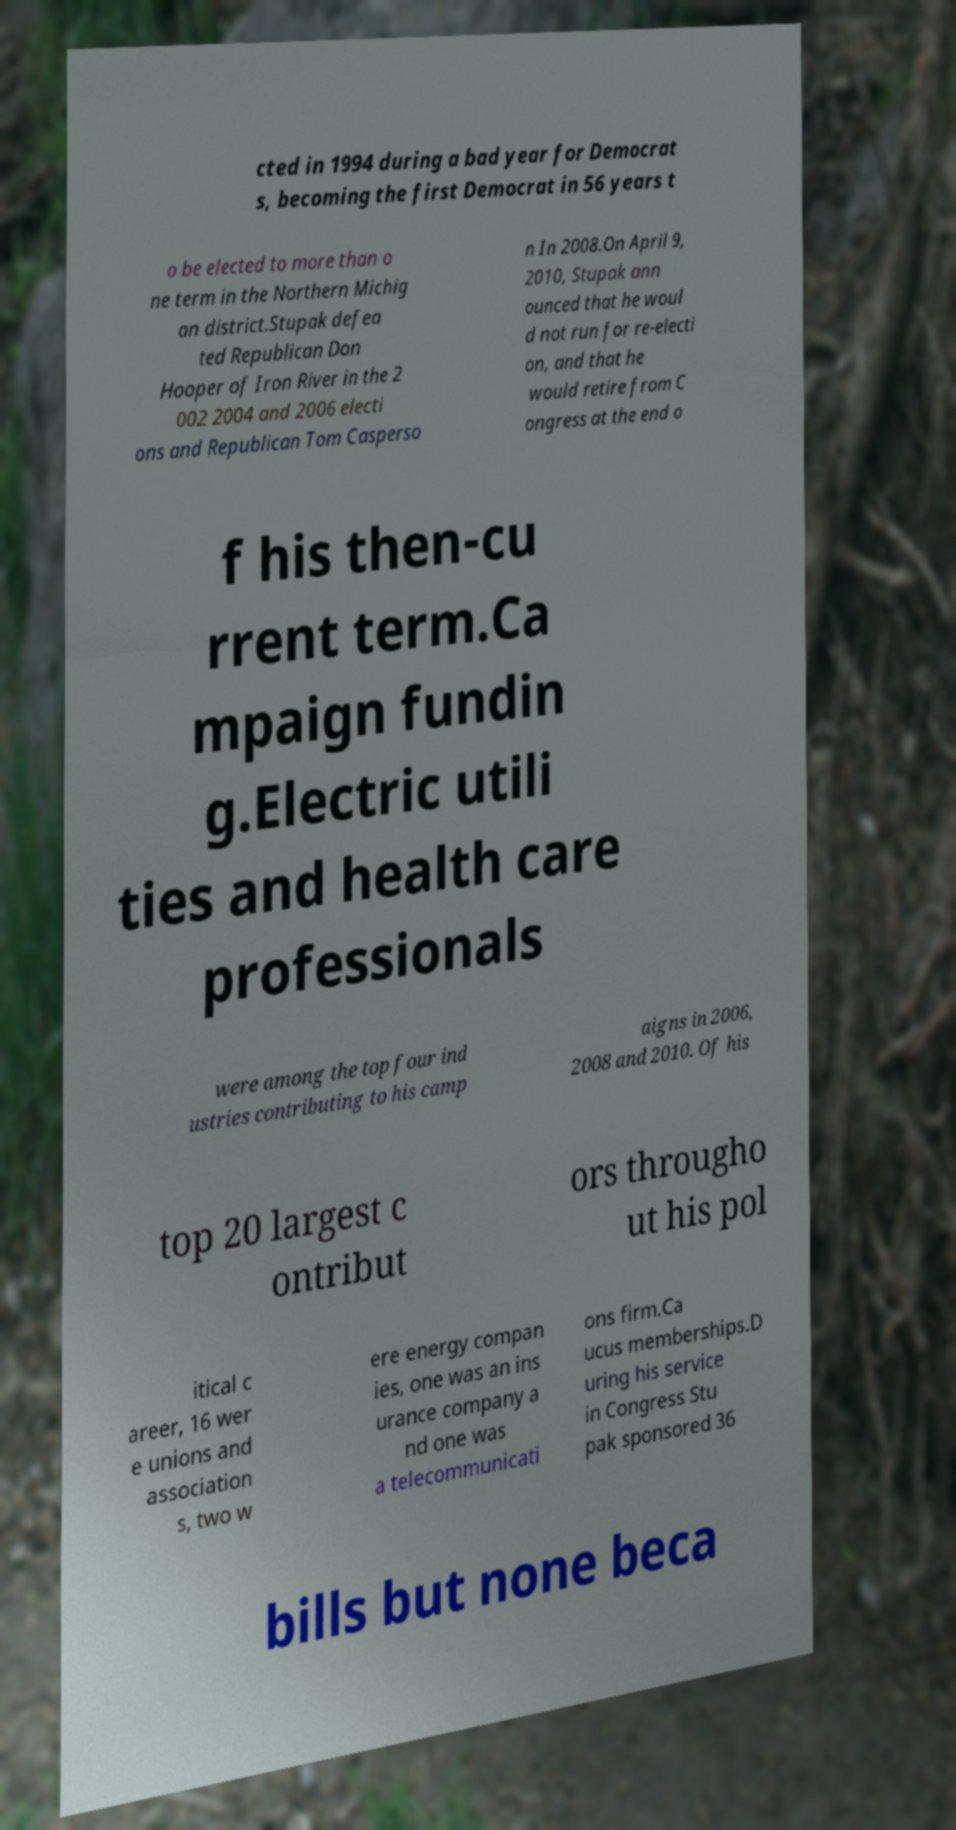Can you read and provide the text displayed in the image?This photo seems to have some interesting text. Can you extract and type it out for me? cted in 1994 during a bad year for Democrat s, becoming the first Democrat in 56 years t o be elected to more than o ne term in the Northern Michig an district.Stupak defea ted Republican Don Hooper of Iron River in the 2 002 2004 and 2006 electi ons and Republican Tom Casperso n In 2008.On April 9, 2010, Stupak ann ounced that he woul d not run for re-electi on, and that he would retire from C ongress at the end o f his then-cu rrent term.Ca mpaign fundin g.Electric utili ties and health care professionals were among the top four ind ustries contributing to his camp aigns in 2006, 2008 and 2010. Of his top 20 largest c ontribut ors througho ut his pol itical c areer, 16 wer e unions and association s, two w ere energy compan ies, one was an ins urance company a nd one was a telecommunicati ons firm.Ca ucus memberships.D uring his service in Congress Stu pak sponsored 36 bills but none beca 